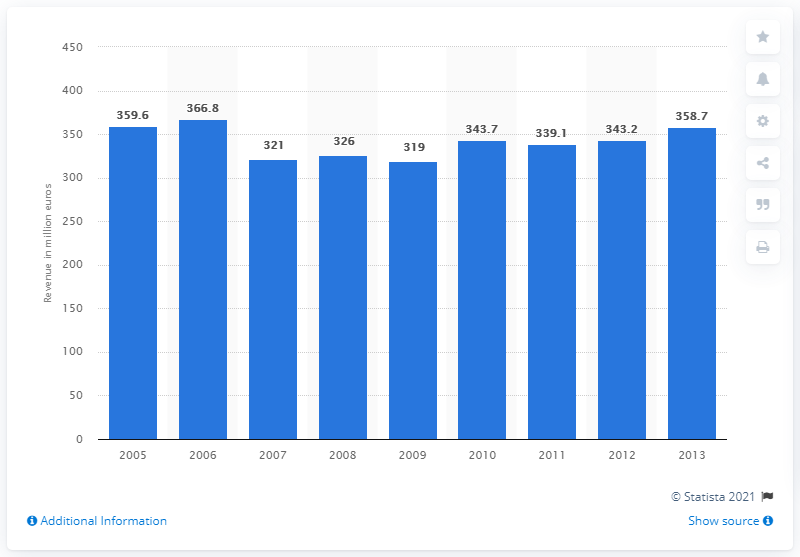Outline some significant characteristics in this image. In 2006, the revenue of Head N.V. was 366.8 million. 